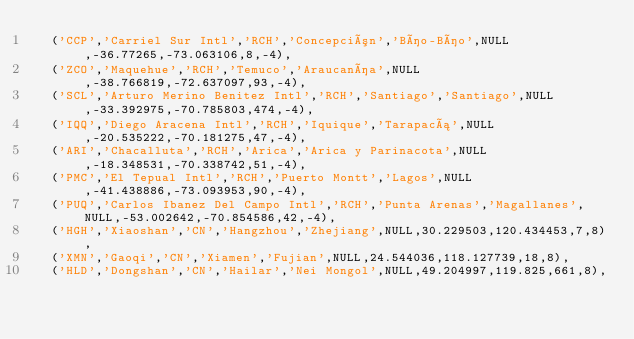Convert code to text. <code><loc_0><loc_0><loc_500><loc_500><_SQL_>	('CCP','Carriel Sur Intl','RCH','Concepción','Bío-Bío',NULL,-36.77265,-73.063106,8,-4),
	('ZCO','Maquehue','RCH','Temuco','Araucanía',NULL,-38.766819,-72.637097,93,-4),
	('SCL','Arturo Merino Benitez Intl','RCH','Santiago','Santiago',NULL,-33.392975,-70.785803,474,-4),
	('IQQ','Diego Aracena Intl','RCH','Iquique','Tarapacá',NULL,-20.535222,-70.181275,47,-4),
	('ARI','Chacalluta','RCH','Arica','Arica y Parinacota',NULL,-18.348531,-70.338742,51,-4),
	('PMC','El Tepual Intl','RCH','Puerto Montt','Lagos',NULL,-41.438886,-73.093953,90,-4),
	('PUQ','Carlos Ibanez Del Campo Intl','RCH','Punta Arenas','Magallanes',NULL,-53.002642,-70.854586,42,-4),
	('HGH','Xiaoshan','CN','Hangzhou','Zhejiang',NULL,30.229503,120.434453,7,8),
	('XMN','Gaoqi','CN','Xiamen','Fujian',NULL,24.544036,118.127739,18,8),
	('HLD','Dongshan','CN','Hailar','Nei Mongol',NULL,49.204997,119.825,661,8),</code> 